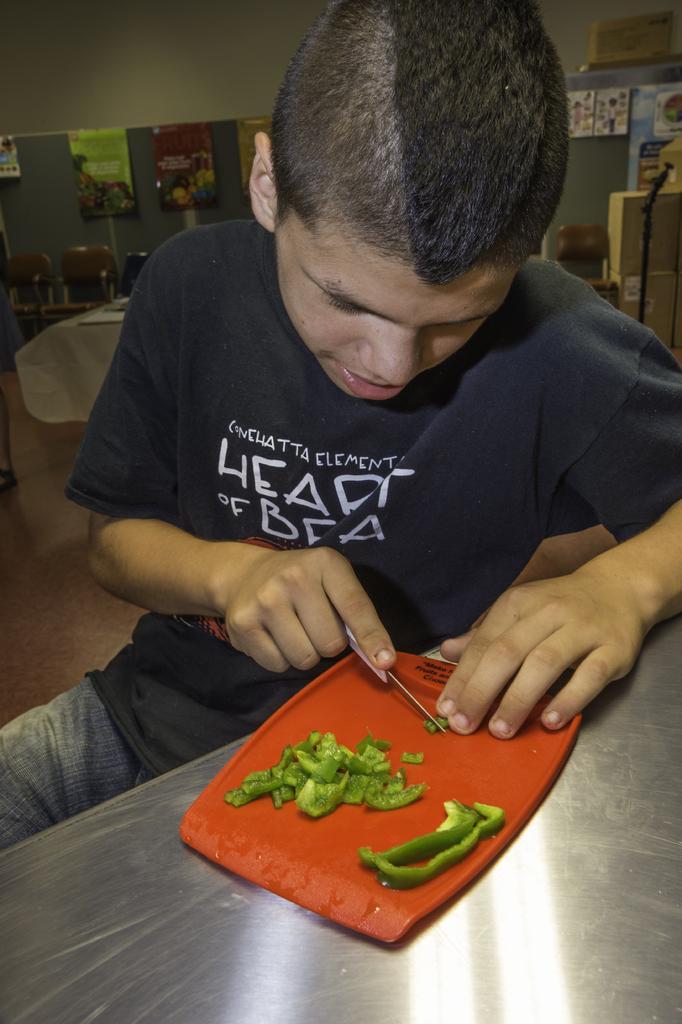How would you summarize this image in a sentence or two? In the image there is a man sitting on chair in front of a table. On table we can see a tray,knife and capsicum in background there is a table and few chairs. 